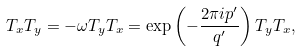Convert formula to latex. <formula><loc_0><loc_0><loc_500><loc_500>T _ { x } T _ { y } = - \omega T _ { y } T _ { x } = \exp \left ( - \frac { 2 \pi i p ^ { \prime } } { q ^ { \prime } } \right ) T _ { y } T _ { x } ,</formula> 